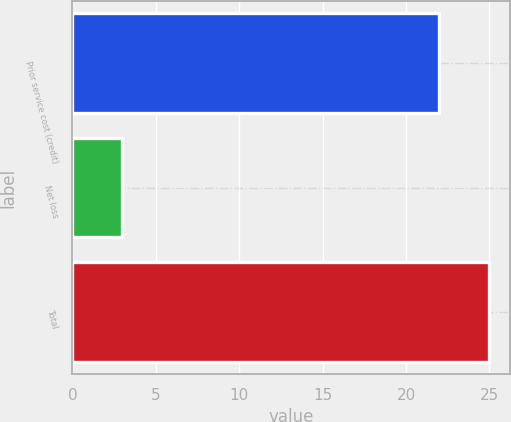Convert chart. <chart><loc_0><loc_0><loc_500><loc_500><bar_chart><fcel>Prior service cost (credit)<fcel>Net loss<fcel>Total<nl><fcel>22<fcel>3<fcel>25<nl></chart> 